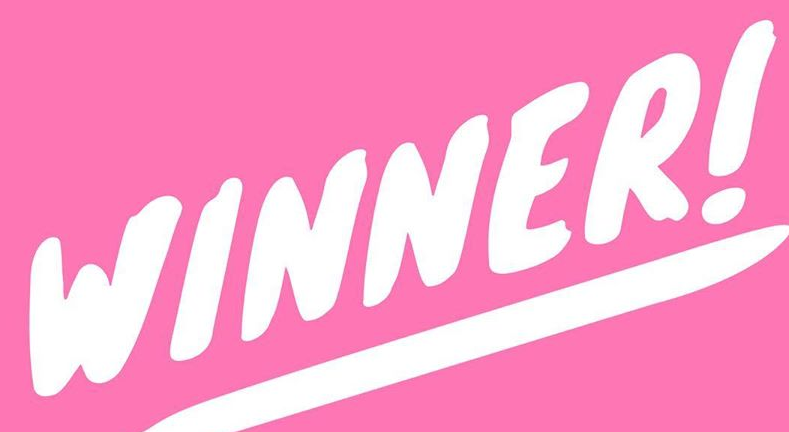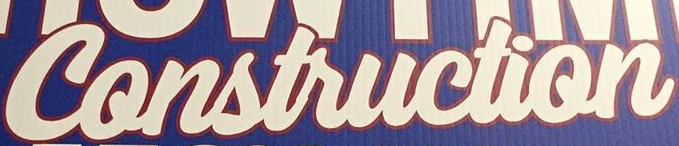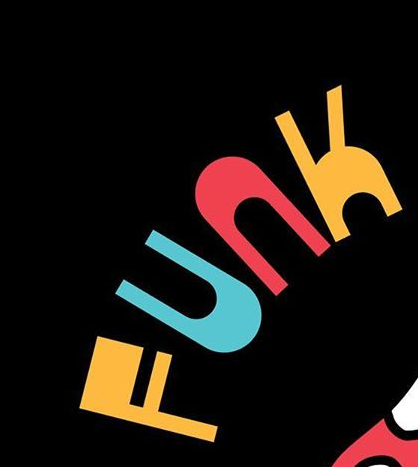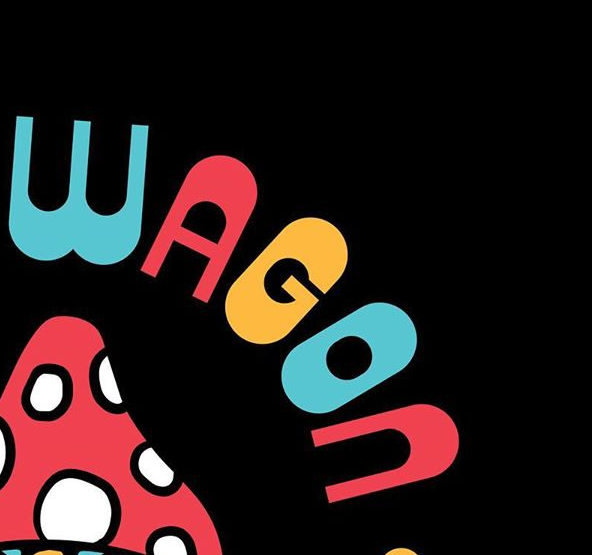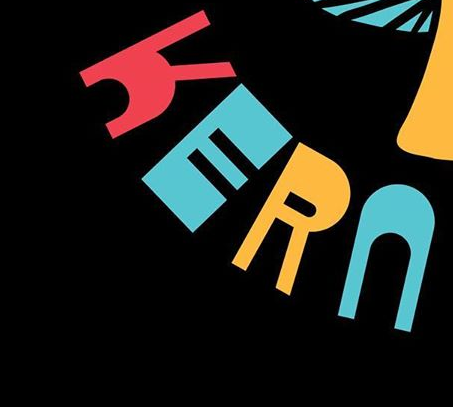What text appears in these images from left to right, separated by a semicolon? WINNER!; Construction; FUNK; WAGON; KERN 